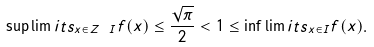Convert formula to latex. <formula><loc_0><loc_0><loc_500><loc_500>\sup \lim i t s _ { x \in { Z } \ I } f ( x ) \leq \frac { \sqrt { \pi } } { 2 } < 1 \leq \inf \lim i t s _ { x \in I } f ( x ) .</formula> 